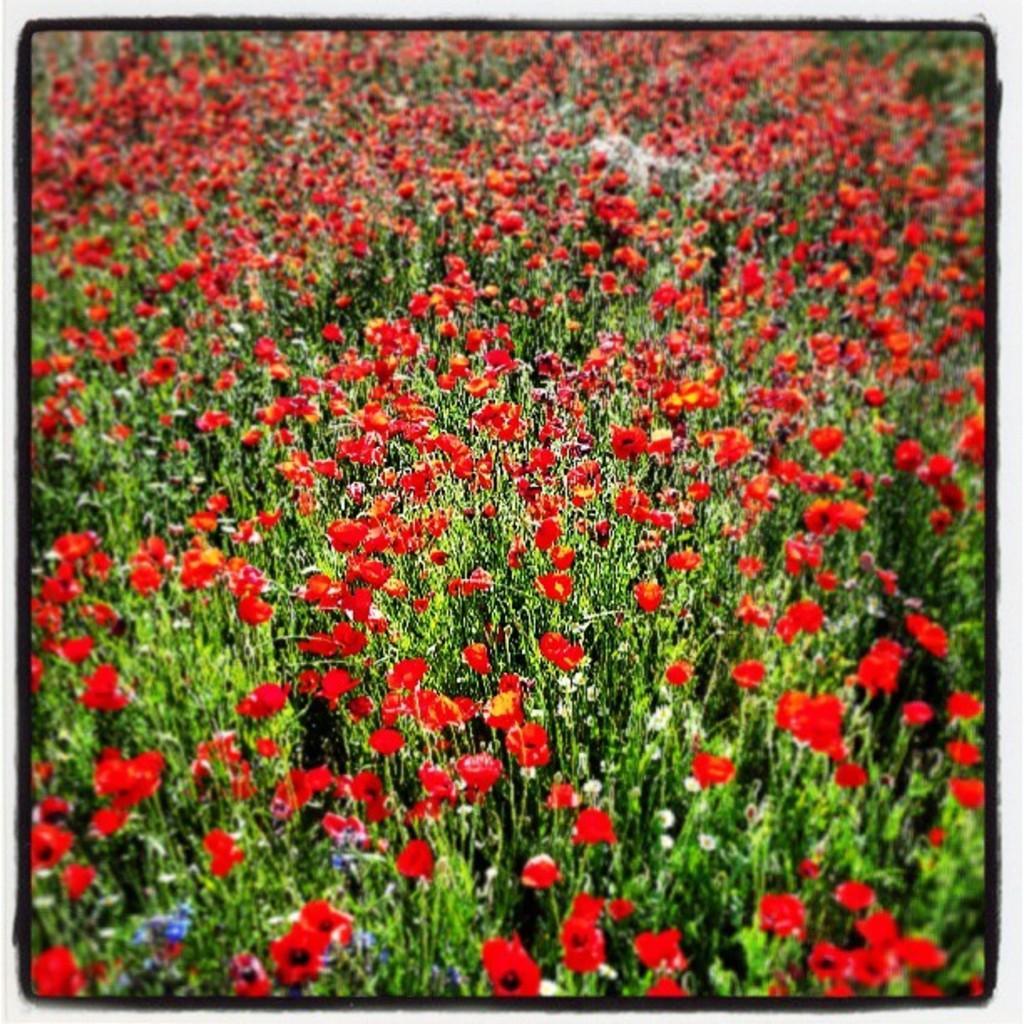Describe this image in one or two sentences. This picture contains plants which are flowering and these flowers are in red color. This picture might be clicked in the garden or in a plant nursery. This picture might be a photo frame. 